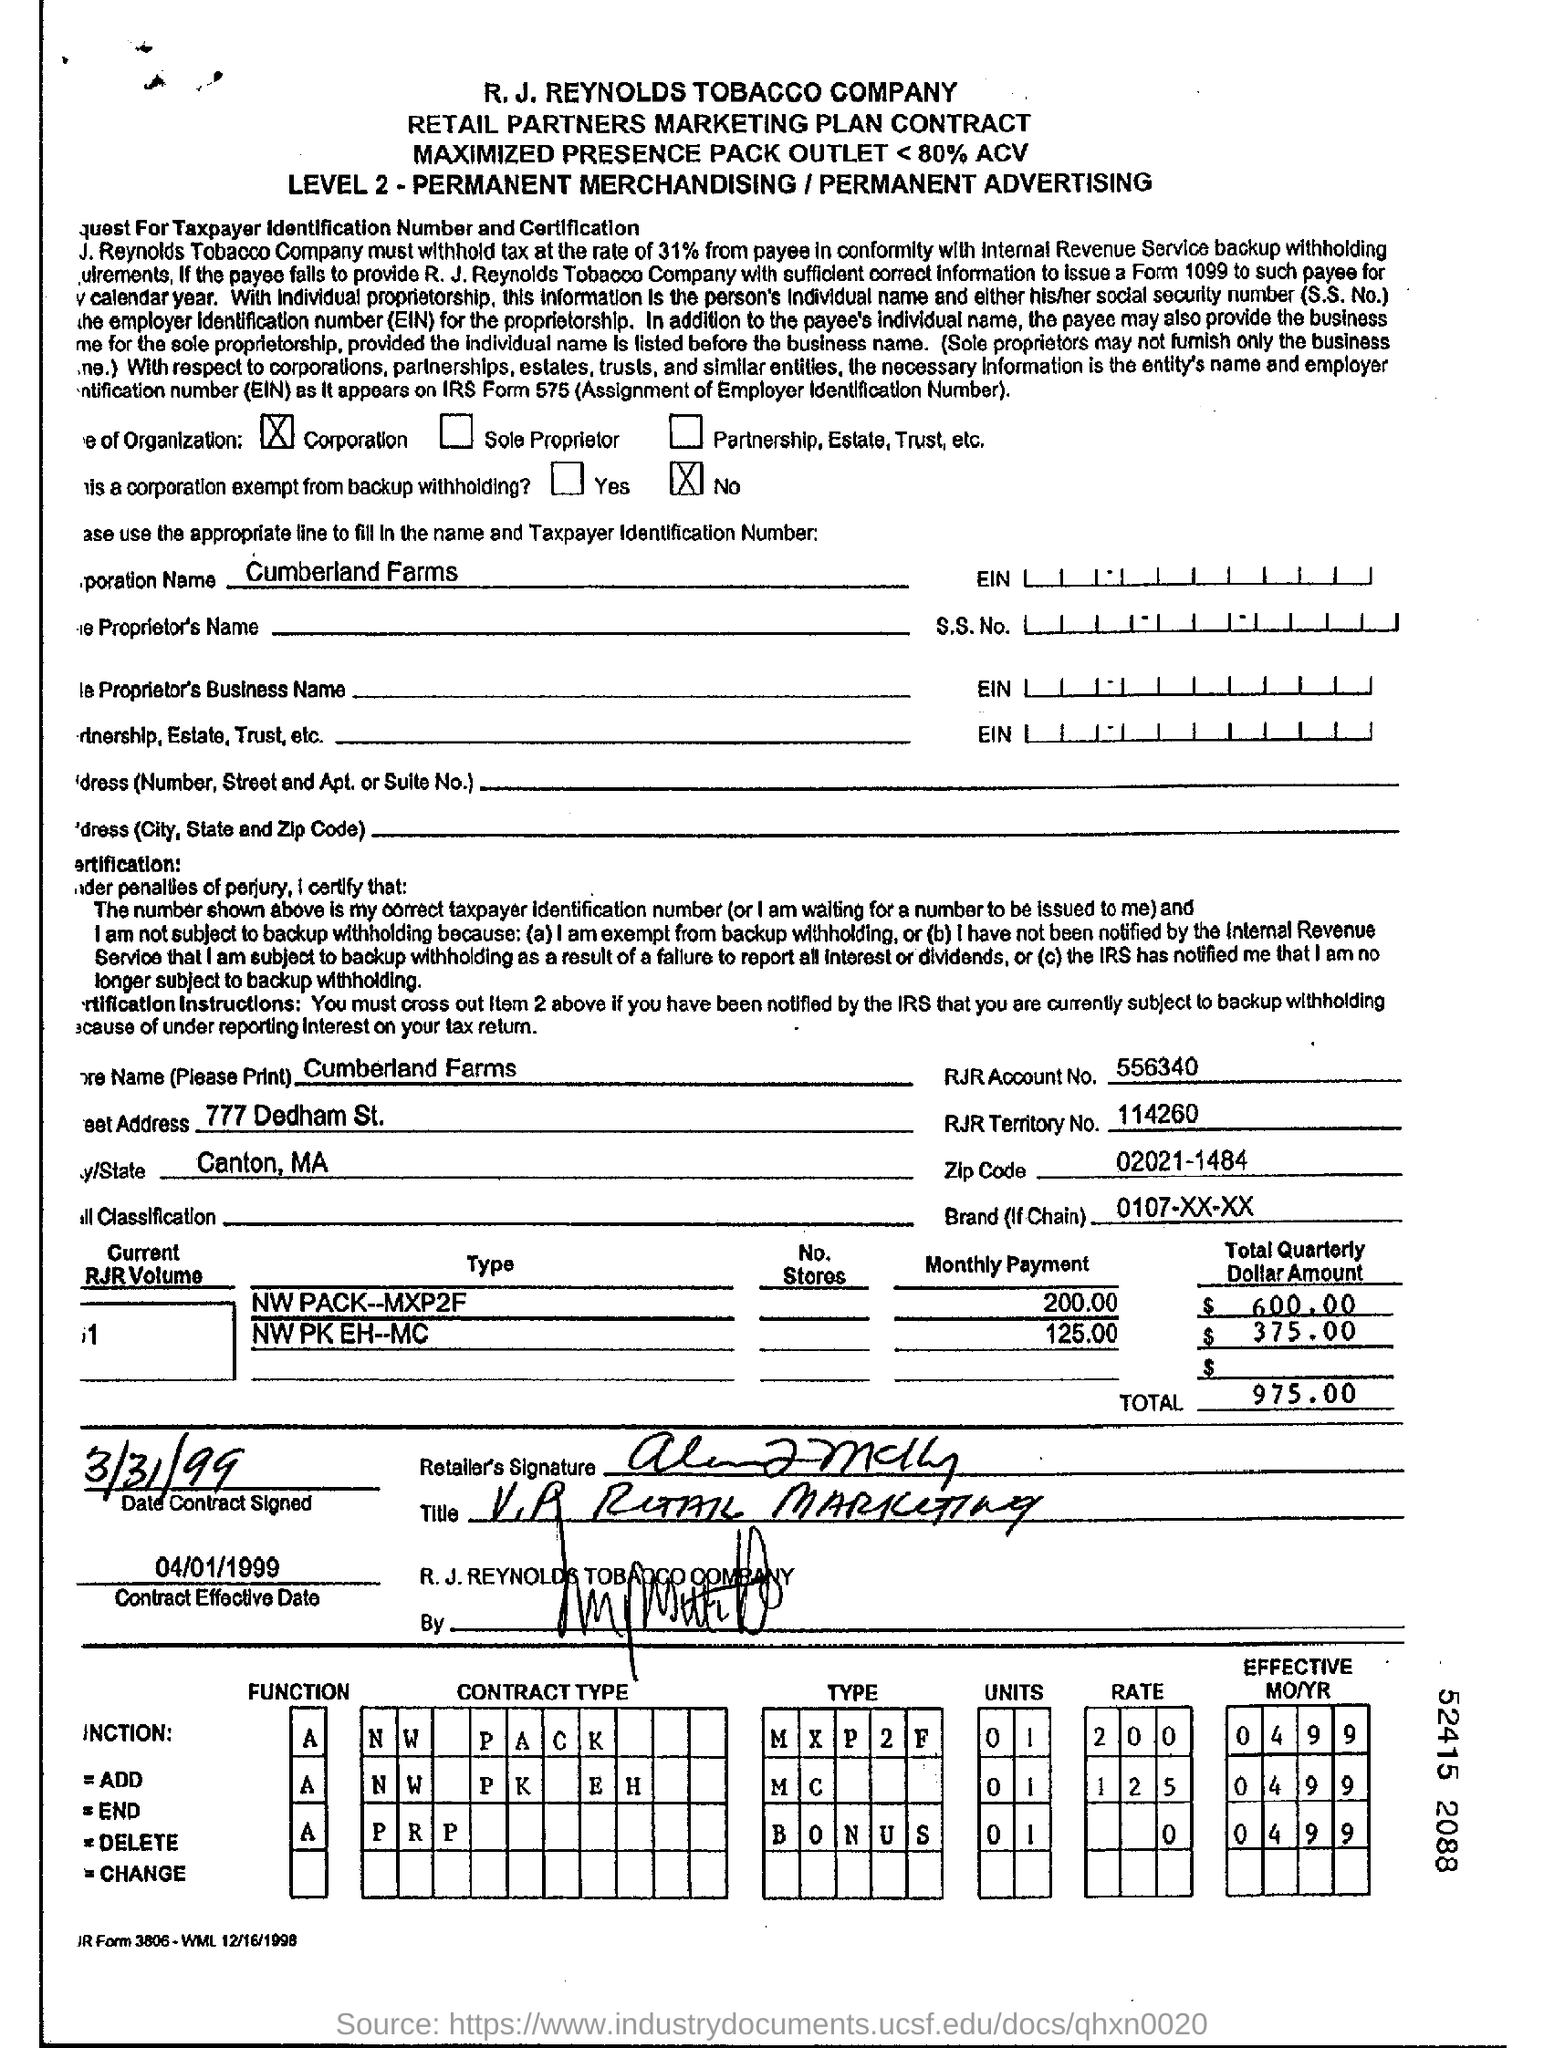Give some essential details in this illustration. The RJR Territory No. is 114260. On the date of March 31, 1999, the contract was signed. The zip code is 02021-1484. The total quarterly dollar amount for Type "NW PACK-MXP2F" is 600.00. The total is 975.00, a significant amount that requires careful consideration. 